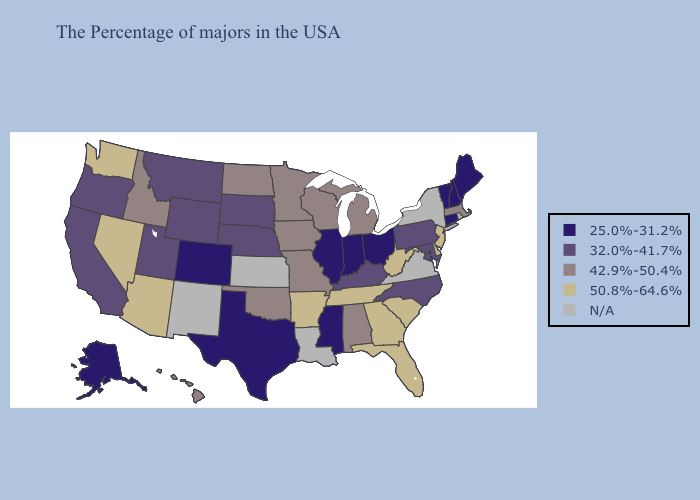What is the value of Wisconsin?
Write a very short answer. 42.9%-50.4%. What is the lowest value in the USA?
Short answer required. 25.0%-31.2%. Does North Dakota have the lowest value in the USA?
Concise answer only. No. What is the value of Massachusetts?
Keep it brief. 42.9%-50.4%. Which states have the highest value in the USA?
Short answer required. New Jersey, Delaware, South Carolina, West Virginia, Florida, Georgia, Tennessee, Arkansas, Arizona, Nevada, Washington. What is the lowest value in states that border New Hampshire?
Write a very short answer. 25.0%-31.2%. Among the states that border Massachusetts , which have the highest value?
Keep it brief. New Hampshire, Vermont, Connecticut. Does New Hampshire have the highest value in the Northeast?
Short answer required. No. Does Montana have the highest value in the USA?
Quick response, please. No. What is the value of Utah?
Answer briefly. 32.0%-41.7%. Name the states that have a value in the range 42.9%-50.4%?
Give a very brief answer. Massachusetts, Michigan, Alabama, Wisconsin, Missouri, Minnesota, Iowa, Oklahoma, North Dakota, Idaho, Hawaii. What is the highest value in the USA?
Keep it brief. 50.8%-64.6%. Name the states that have a value in the range 32.0%-41.7%?
Be succinct. Maryland, Pennsylvania, North Carolina, Kentucky, Nebraska, South Dakota, Wyoming, Utah, Montana, California, Oregon. What is the value of Connecticut?
Write a very short answer. 25.0%-31.2%. Name the states that have a value in the range 32.0%-41.7%?
Give a very brief answer. Maryland, Pennsylvania, North Carolina, Kentucky, Nebraska, South Dakota, Wyoming, Utah, Montana, California, Oregon. 